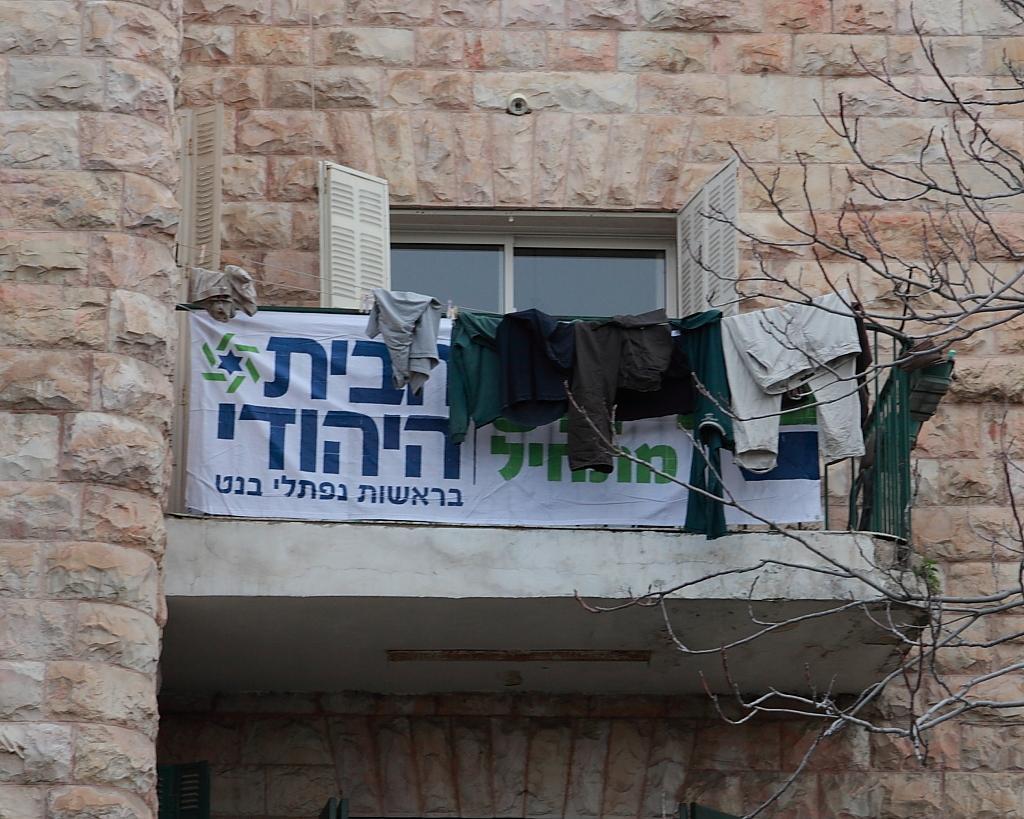Please provide a concise description of this image. In the picture I can see the balcony. I can see the metal fence and there is a banner on the metal fence. I can see the clothes on the rope. It is looking a deciduous tree on the right side. I can see the glass window. 